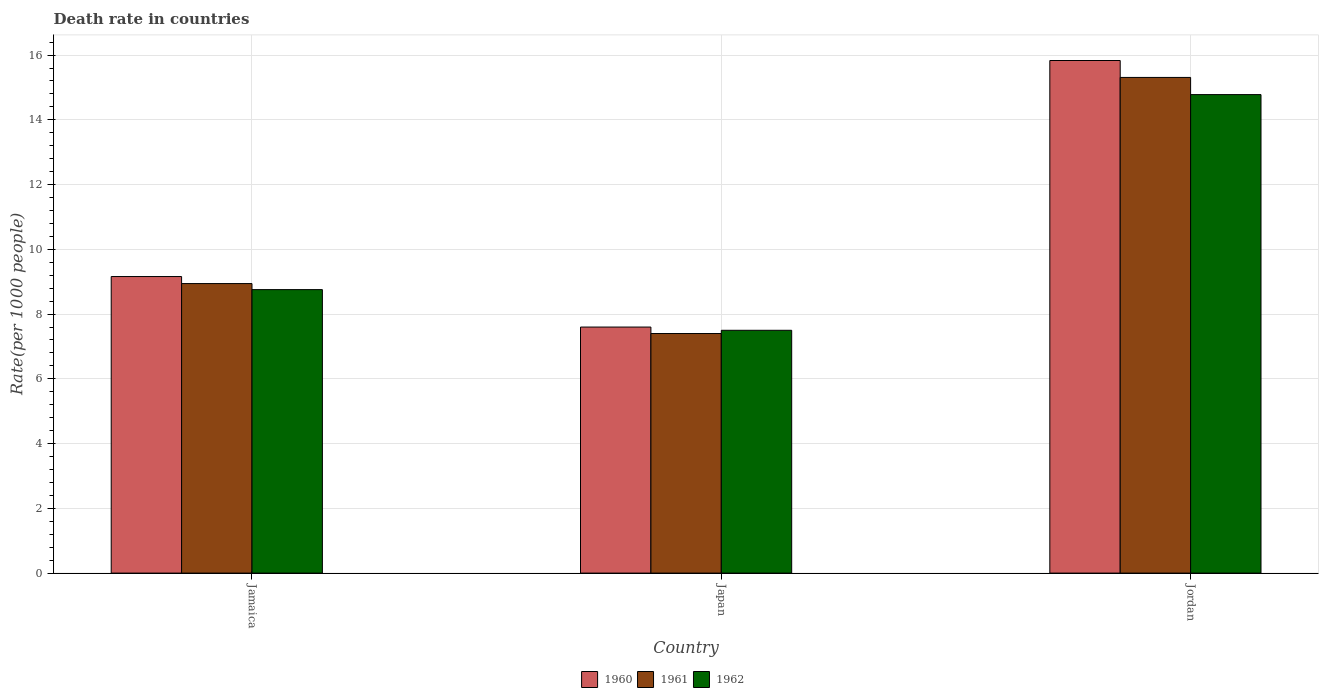How many different coloured bars are there?
Give a very brief answer. 3. What is the label of the 2nd group of bars from the left?
Offer a very short reply. Japan. In how many cases, is the number of bars for a given country not equal to the number of legend labels?
Offer a very short reply. 0. What is the death rate in 1962 in Jordan?
Offer a very short reply. 14.78. Across all countries, what is the maximum death rate in 1962?
Offer a terse response. 14.78. Across all countries, what is the minimum death rate in 1962?
Your response must be concise. 7.5. In which country was the death rate in 1960 maximum?
Offer a terse response. Jordan. In which country was the death rate in 1962 minimum?
Provide a short and direct response. Japan. What is the total death rate in 1961 in the graph?
Ensure brevity in your answer.  31.65. What is the difference between the death rate in 1960 in Japan and that in Jordan?
Offer a very short reply. -8.23. What is the difference between the death rate in 1962 in Japan and the death rate in 1960 in Jordan?
Offer a very short reply. -8.33. What is the average death rate in 1962 per country?
Give a very brief answer. 10.35. What is the difference between the death rate of/in 1960 and death rate of/in 1962 in Jordan?
Provide a succinct answer. 1.05. In how many countries, is the death rate in 1960 greater than 9.2?
Offer a terse response. 1. What is the ratio of the death rate in 1962 in Jamaica to that in Jordan?
Your answer should be compact. 0.59. Is the difference between the death rate in 1960 in Jamaica and Jordan greater than the difference between the death rate in 1962 in Jamaica and Jordan?
Give a very brief answer. No. What is the difference between the highest and the second highest death rate in 1962?
Offer a very short reply. -6.02. What is the difference between the highest and the lowest death rate in 1960?
Your response must be concise. 8.23. In how many countries, is the death rate in 1960 greater than the average death rate in 1960 taken over all countries?
Ensure brevity in your answer.  1. What does the 1st bar from the left in Jamaica represents?
Offer a terse response. 1960. What does the 2nd bar from the right in Japan represents?
Make the answer very short. 1961. How many bars are there?
Offer a very short reply. 9. How many countries are there in the graph?
Keep it short and to the point. 3. What is the difference between two consecutive major ticks on the Y-axis?
Make the answer very short. 2. Are the values on the major ticks of Y-axis written in scientific E-notation?
Offer a terse response. No. Does the graph contain any zero values?
Your answer should be very brief. No. What is the title of the graph?
Provide a succinct answer. Death rate in countries. Does "1971" appear as one of the legend labels in the graph?
Make the answer very short. No. What is the label or title of the X-axis?
Provide a short and direct response. Country. What is the label or title of the Y-axis?
Your answer should be very brief. Rate(per 1000 people). What is the Rate(per 1000 people) of 1960 in Jamaica?
Make the answer very short. 9.16. What is the Rate(per 1000 people) in 1961 in Jamaica?
Ensure brevity in your answer.  8.94. What is the Rate(per 1000 people) in 1962 in Jamaica?
Give a very brief answer. 8.76. What is the Rate(per 1000 people) in 1960 in Japan?
Provide a short and direct response. 7.6. What is the Rate(per 1000 people) in 1962 in Japan?
Your answer should be very brief. 7.5. What is the Rate(per 1000 people) in 1960 in Jordan?
Your answer should be compact. 15.83. What is the Rate(per 1000 people) in 1961 in Jordan?
Ensure brevity in your answer.  15.31. What is the Rate(per 1000 people) in 1962 in Jordan?
Your answer should be compact. 14.78. Across all countries, what is the maximum Rate(per 1000 people) of 1960?
Offer a terse response. 15.83. Across all countries, what is the maximum Rate(per 1000 people) in 1961?
Provide a succinct answer. 15.31. Across all countries, what is the maximum Rate(per 1000 people) of 1962?
Offer a very short reply. 14.78. Across all countries, what is the minimum Rate(per 1000 people) of 1962?
Your answer should be very brief. 7.5. What is the total Rate(per 1000 people) in 1960 in the graph?
Offer a terse response. 32.59. What is the total Rate(per 1000 people) in 1961 in the graph?
Make the answer very short. 31.65. What is the total Rate(per 1000 people) of 1962 in the graph?
Your answer should be compact. 31.04. What is the difference between the Rate(per 1000 people) of 1960 in Jamaica and that in Japan?
Keep it short and to the point. 1.56. What is the difference between the Rate(per 1000 people) of 1961 in Jamaica and that in Japan?
Offer a very short reply. 1.54. What is the difference between the Rate(per 1000 people) in 1962 in Jamaica and that in Japan?
Offer a very short reply. 1.26. What is the difference between the Rate(per 1000 people) in 1960 in Jamaica and that in Jordan?
Keep it short and to the point. -6.67. What is the difference between the Rate(per 1000 people) of 1961 in Jamaica and that in Jordan?
Provide a short and direct response. -6.37. What is the difference between the Rate(per 1000 people) of 1962 in Jamaica and that in Jordan?
Provide a succinct answer. -6.02. What is the difference between the Rate(per 1000 people) in 1960 in Japan and that in Jordan?
Offer a terse response. -8.23. What is the difference between the Rate(per 1000 people) of 1961 in Japan and that in Jordan?
Your response must be concise. -7.91. What is the difference between the Rate(per 1000 people) of 1962 in Japan and that in Jordan?
Ensure brevity in your answer.  -7.28. What is the difference between the Rate(per 1000 people) in 1960 in Jamaica and the Rate(per 1000 people) in 1961 in Japan?
Offer a very short reply. 1.76. What is the difference between the Rate(per 1000 people) of 1960 in Jamaica and the Rate(per 1000 people) of 1962 in Japan?
Offer a very short reply. 1.66. What is the difference between the Rate(per 1000 people) in 1961 in Jamaica and the Rate(per 1000 people) in 1962 in Japan?
Keep it short and to the point. 1.44. What is the difference between the Rate(per 1000 people) in 1960 in Jamaica and the Rate(per 1000 people) in 1961 in Jordan?
Ensure brevity in your answer.  -6.15. What is the difference between the Rate(per 1000 people) of 1960 in Jamaica and the Rate(per 1000 people) of 1962 in Jordan?
Provide a short and direct response. -5.62. What is the difference between the Rate(per 1000 people) in 1961 in Jamaica and the Rate(per 1000 people) in 1962 in Jordan?
Provide a short and direct response. -5.84. What is the difference between the Rate(per 1000 people) of 1960 in Japan and the Rate(per 1000 people) of 1961 in Jordan?
Your response must be concise. -7.71. What is the difference between the Rate(per 1000 people) of 1960 in Japan and the Rate(per 1000 people) of 1962 in Jordan?
Provide a succinct answer. -7.18. What is the difference between the Rate(per 1000 people) in 1961 in Japan and the Rate(per 1000 people) in 1962 in Jordan?
Your answer should be very brief. -7.38. What is the average Rate(per 1000 people) of 1960 per country?
Offer a very short reply. 10.86. What is the average Rate(per 1000 people) in 1961 per country?
Ensure brevity in your answer.  10.55. What is the average Rate(per 1000 people) of 1962 per country?
Give a very brief answer. 10.35. What is the difference between the Rate(per 1000 people) in 1960 and Rate(per 1000 people) in 1961 in Jamaica?
Ensure brevity in your answer.  0.22. What is the difference between the Rate(per 1000 people) of 1960 and Rate(per 1000 people) of 1962 in Jamaica?
Provide a succinct answer. 0.4. What is the difference between the Rate(per 1000 people) in 1961 and Rate(per 1000 people) in 1962 in Jamaica?
Provide a short and direct response. 0.19. What is the difference between the Rate(per 1000 people) of 1960 and Rate(per 1000 people) of 1961 in Japan?
Provide a short and direct response. 0.2. What is the difference between the Rate(per 1000 people) of 1960 and Rate(per 1000 people) of 1962 in Japan?
Provide a short and direct response. 0.1. What is the difference between the Rate(per 1000 people) in 1960 and Rate(per 1000 people) in 1961 in Jordan?
Ensure brevity in your answer.  0.52. What is the difference between the Rate(per 1000 people) in 1960 and Rate(per 1000 people) in 1962 in Jordan?
Give a very brief answer. 1.05. What is the difference between the Rate(per 1000 people) of 1961 and Rate(per 1000 people) of 1962 in Jordan?
Give a very brief answer. 0.53. What is the ratio of the Rate(per 1000 people) in 1960 in Jamaica to that in Japan?
Your answer should be very brief. 1.21. What is the ratio of the Rate(per 1000 people) in 1961 in Jamaica to that in Japan?
Provide a succinct answer. 1.21. What is the ratio of the Rate(per 1000 people) of 1962 in Jamaica to that in Japan?
Provide a short and direct response. 1.17. What is the ratio of the Rate(per 1000 people) of 1960 in Jamaica to that in Jordan?
Your answer should be very brief. 0.58. What is the ratio of the Rate(per 1000 people) in 1961 in Jamaica to that in Jordan?
Your answer should be very brief. 0.58. What is the ratio of the Rate(per 1000 people) in 1962 in Jamaica to that in Jordan?
Ensure brevity in your answer.  0.59. What is the ratio of the Rate(per 1000 people) in 1960 in Japan to that in Jordan?
Keep it short and to the point. 0.48. What is the ratio of the Rate(per 1000 people) in 1961 in Japan to that in Jordan?
Offer a very short reply. 0.48. What is the ratio of the Rate(per 1000 people) of 1962 in Japan to that in Jordan?
Your answer should be compact. 0.51. What is the difference between the highest and the second highest Rate(per 1000 people) of 1960?
Keep it short and to the point. 6.67. What is the difference between the highest and the second highest Rate(per 1000 people) of 1961?
Make the answer very short. 6.37. What is the difference between the highest and the second highest Rate(per 1000 people) in 1962?
Keep it short and to the point. 6.02. What is the difference between the highest and the lowest Rate(per 1000 people) in 1960?
Offer a very short reply. 8.23. What is the difference between the highest and the lowest Rate(per 1000 people) of 1961?
Your answer should be very brief. 7.91. What is the difference between the highest and the lowest Rate(per 1000 people) of 1962?
Your response must be concise. 7.28. 